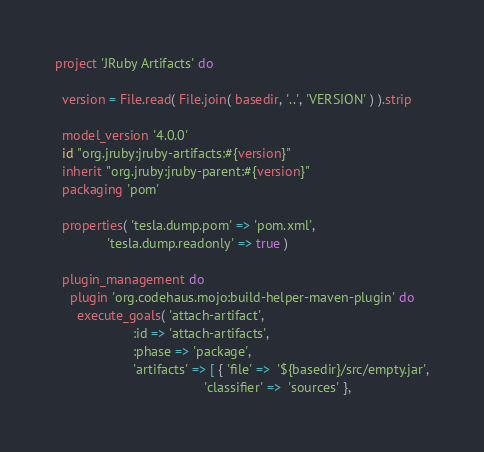<code> <loc_0><loc_0><loc_500><loc_500><_Ruby_>project 'JRuby Artifacts' do

  version = File.read( File.join( basedir, '..', 'VERSION' ) ).strip

  model_version '4.0.0'
  id "org.jruby:jruby-artifacts:#{version}"
  inherit "org.jruby:jruby-parent:#{version}"
  packaging 'pom'

  properties( 'tesla.dump.pom' => 'pom.xml',
              'tesla.dump.readonly' => true )

  plugin_management do
    plugin 'org.codehaus.mojo:build-helper-maven-plugin' do
      execute_goals( 'attach-artifact',
                     :id => 'attach-artifacts',
                     :phase => 'package',
                     'artifacts' => [ { 'file' =>  '${basedir}/src/empty.jar',
                                        'classifier' =>  'sources' },</code> 